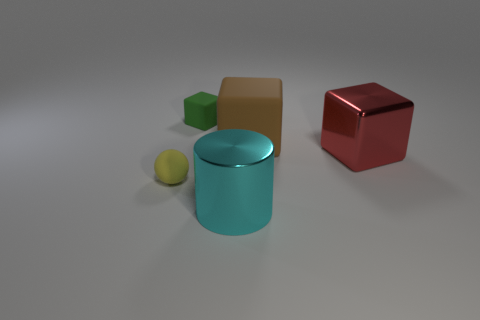How many objects are either tiny things that are behind the big red thing or small yellow metal blocks?
Make the answer very short. 1. Are there fewer green blocks than yellow shiny balls?
Give a very brief answer. No. There is a brown thing that is made of the same material as the yellow thing; what is its shape?
Offer a terse response. Cube. There is a red thing; are there any yellow spheres behind it?
Offer a very short reply. No. Is the number of blocks that are on the left side of the big cylinder less than the number of tiny yellow matte objects?
Give a very brief answer. No. What is the material of the green object?
Give a very brief answer. Rubber. The large matte block has what color?
Provide a succinct answer. Brown. There is a large thing that is in front of the brown rubber cube and on the right side of the big cyan cylinder; what is its color?
Ensure brevity in your answer.  Red. Are the green block and the thing in front of the yellow object made of the same material?
Ensure brevity in your answer.  No. What is the size of the object that is in front of the small matte object that is in front of the small block?
Your response must be concise. Large. 